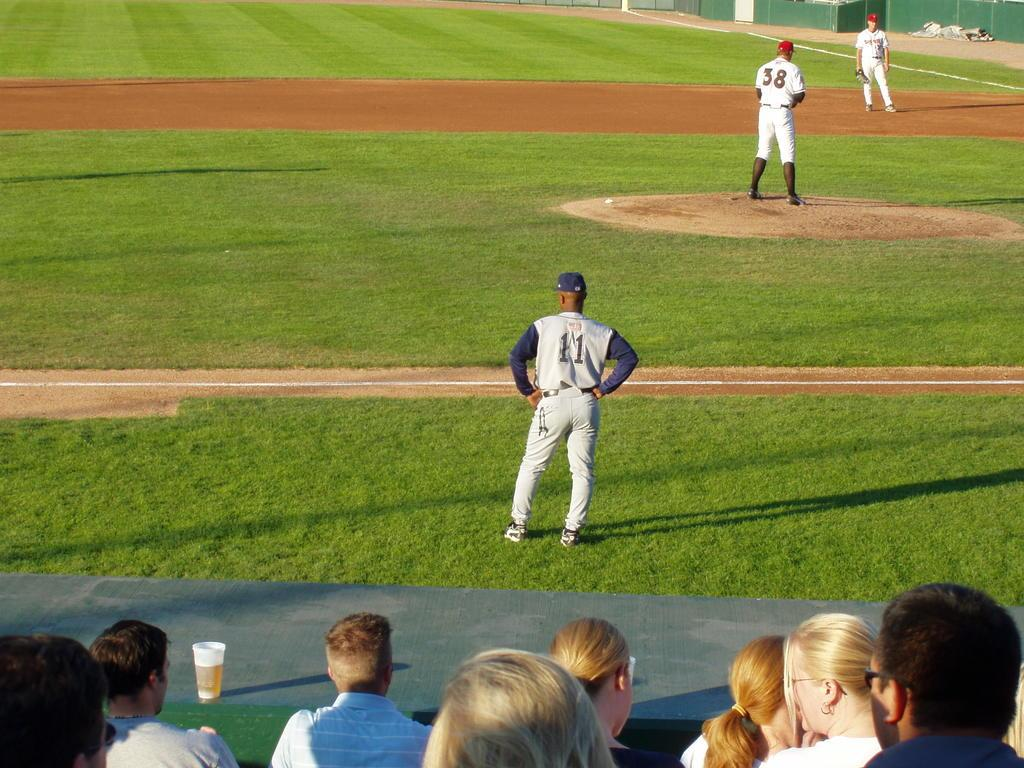<image>
Provide a brief description of the given image. A man wearing a number 11 baseball jersey surveys the field. 